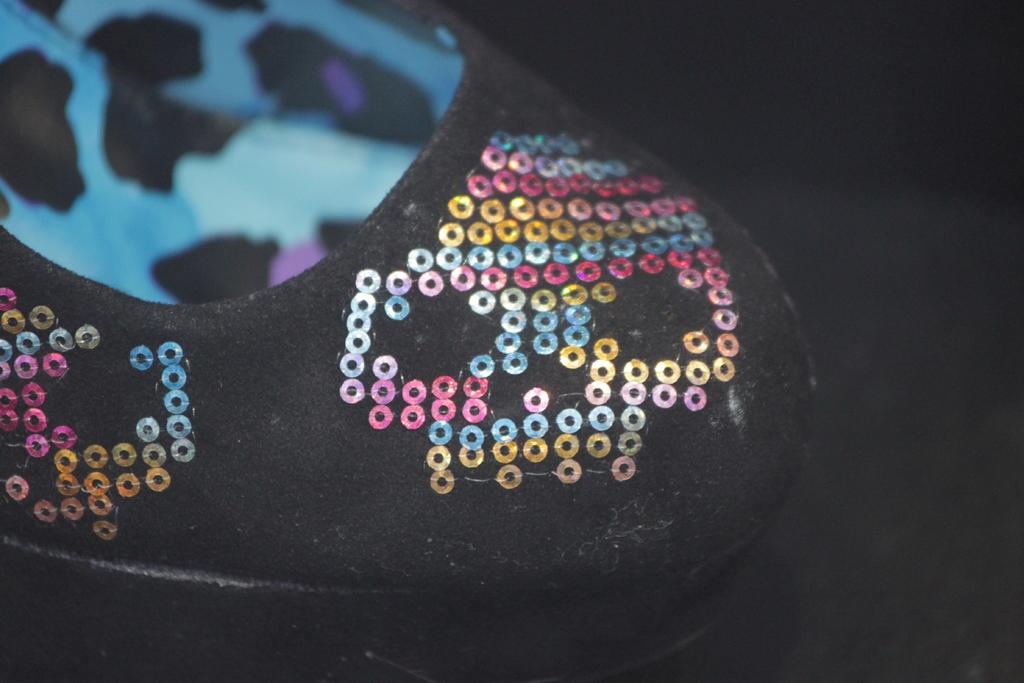What object is the main subject of the image? There is a shoe in the image. What can be observed about the background of the image? The background of the image is dark. How many bricks are used to construct the carriage in the image? There is no carriage or bricks present in the image; it features a shoe and a dark background. 